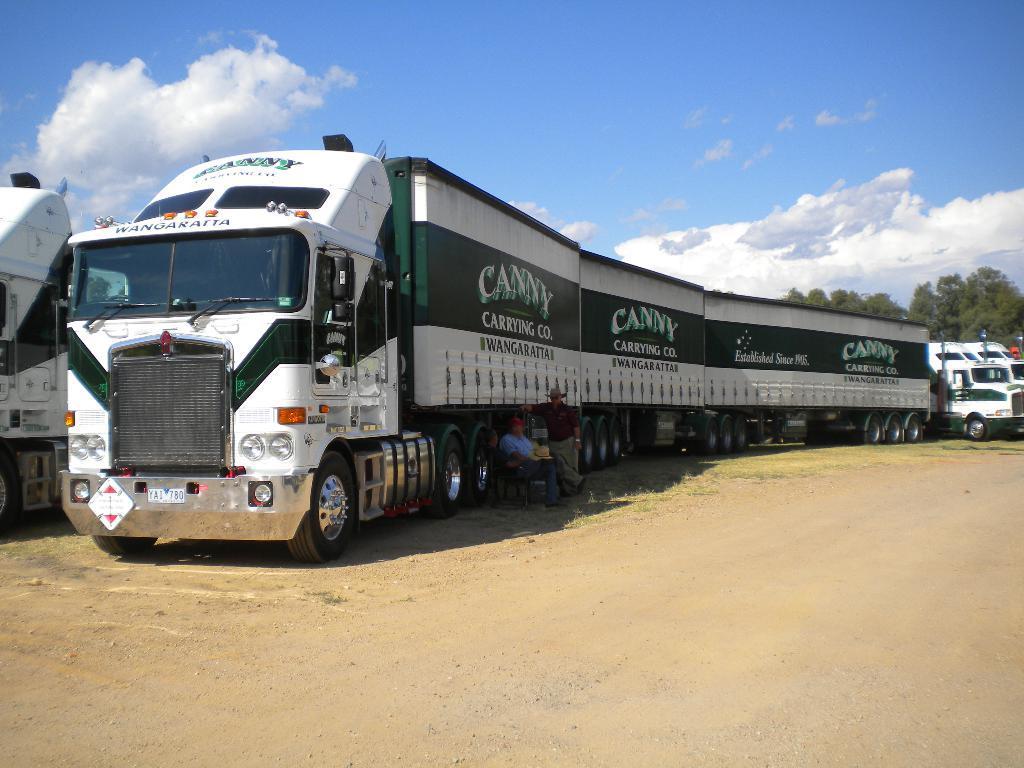Please provide a concise description of this image. In this image I can see few white colour trucks and few people where two are sitting and one is standing. In the background I can see trees, cloud, the sky and here I can see something is written. 